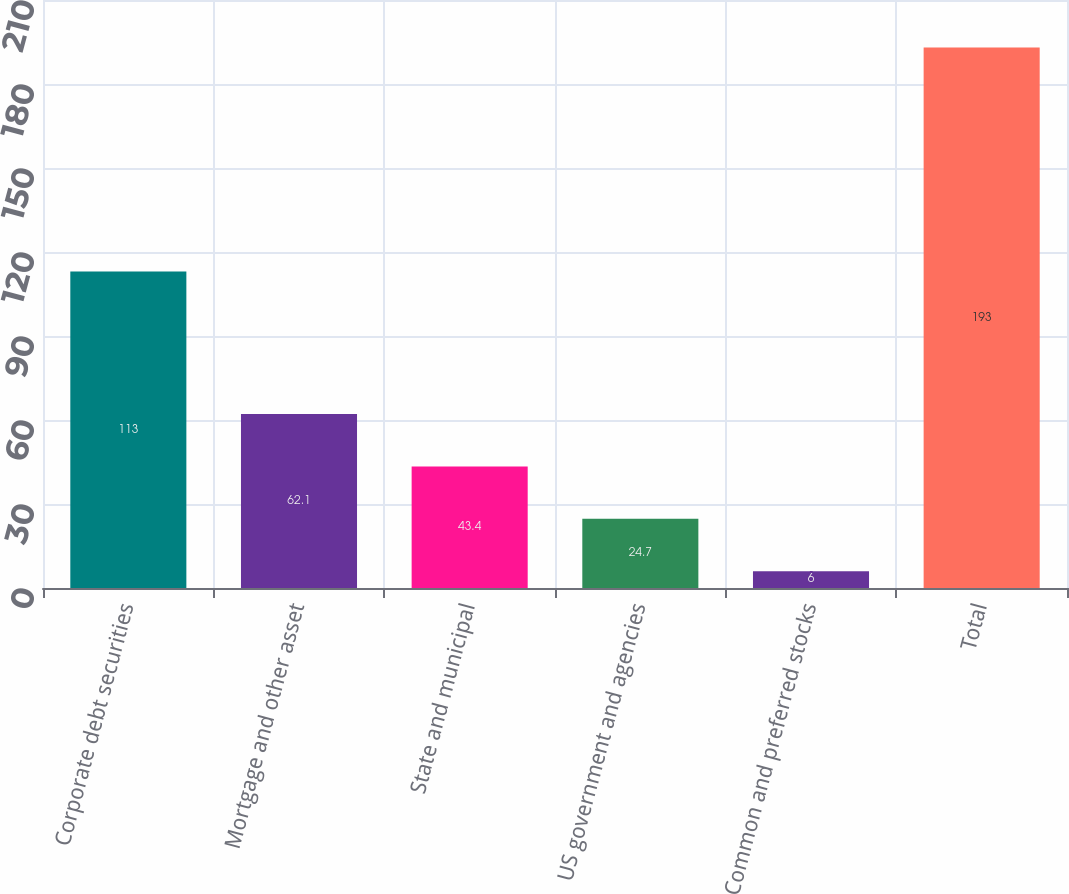Convert chart. <chart><loc_0><loc_0><loc_500><loc_500><bar_chart><fcel>Corporate debt securities<fcel>Mortgage and other asset<fcel>State and municipal<fcel>US government and agencies<fcel>Common and preferred stocks<fcel>Total<nl><fcel>113<fcel>62.1<fcel>43.4<fcel>24.7<fcel>6<fcel>193<nl></chart> 